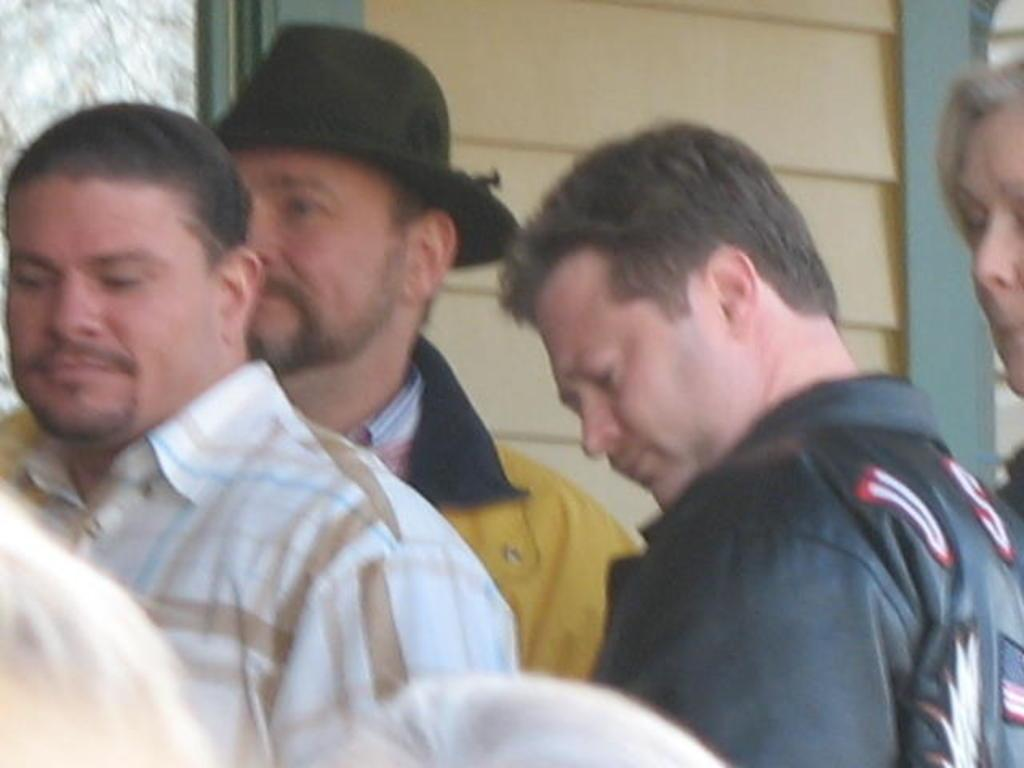What is located in the front of the image? There are persons in the front of the image. What can be seen in the background of the image? There is a wall in the background of the image. Can you describe the object in the background of the image? The object in the background of the image is brown and green in color. What type of skirt is the wall wearing in the image? The wall is not a person and therefore cannot wear a skirt. Can you tell me how many straws are visible in the image? There is no mention of straws in the provided facts, so it cannot be determined if any are visible in the image. 